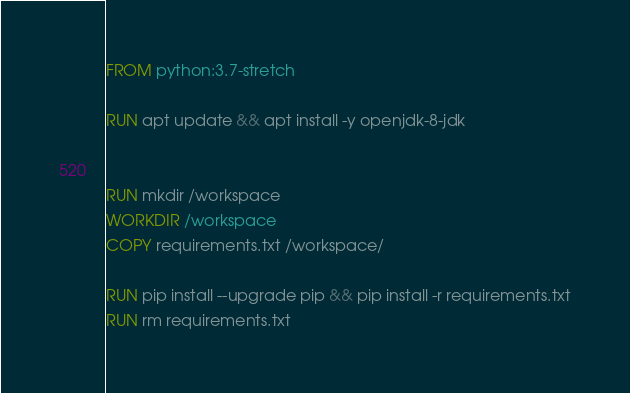Convert code to text. <code><loc_0><loc_0><loc_500><loc_500><_Dockerfile_>FROM python:3.7-stretch

RUN apt update && apt install -y openjdk-8-jdk


RUN mkdir /workspace
WORKDIR /workspace
COPY requirements.txt /workspace/

RUN pip install --upgrade pip && pip install -r requirements.txt
RUN rm requirements.txt</code> 